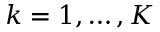Convert formula to latex. <formula><loc_0><loc_0><loc_500><loc_500>k = 1 , \dots , K</formula> 